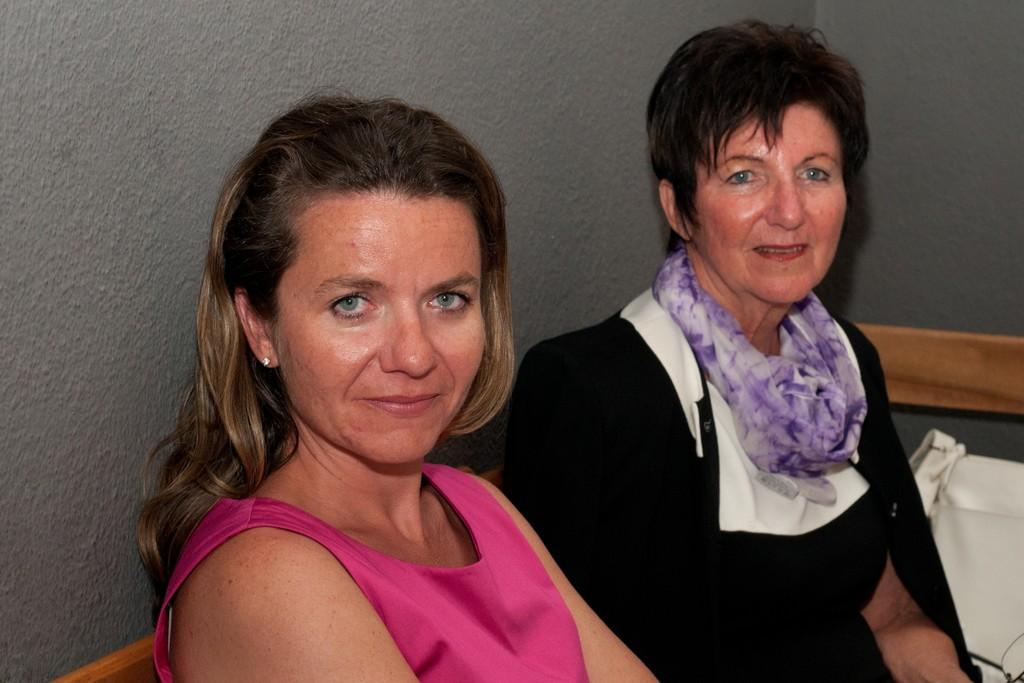How many people are in the image? There are two women in the image. What are the women doing in the image? The women are sitting and smiling. What can be seen in the image besides the women? There is a white bag in the image. What is visible in the background of the image? There is a wall in the background of the image. Are there any fairies flying around the women in the image? No, there are no fairies present in the image. What type of cave can be seen in the background of the image? There is no cave visible in the background of the image; it features a wall. 